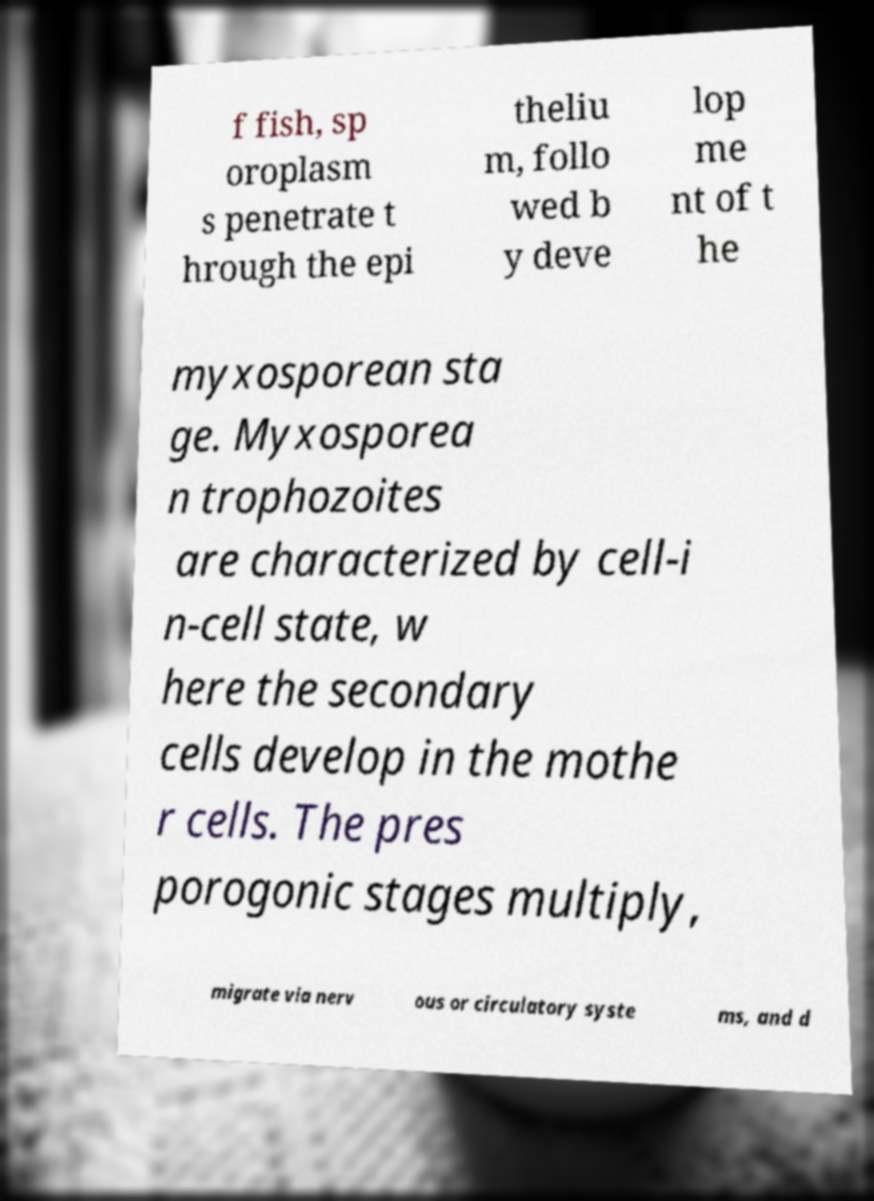I need the written content from this picture converted into text. Can you do that? f fish, sp oroplasm s penetrate t hrough the epi theliu m, follo wed b y deve lop me nt of t he myxosporean sta ge. Myxosporea n trophozoites are characterized by cell-i n-cell state, w here the secondary cells develop in the mothe r cells. The pres porogonic stages multiply, migrate via nerv ous or circulatory syste ms, and d 